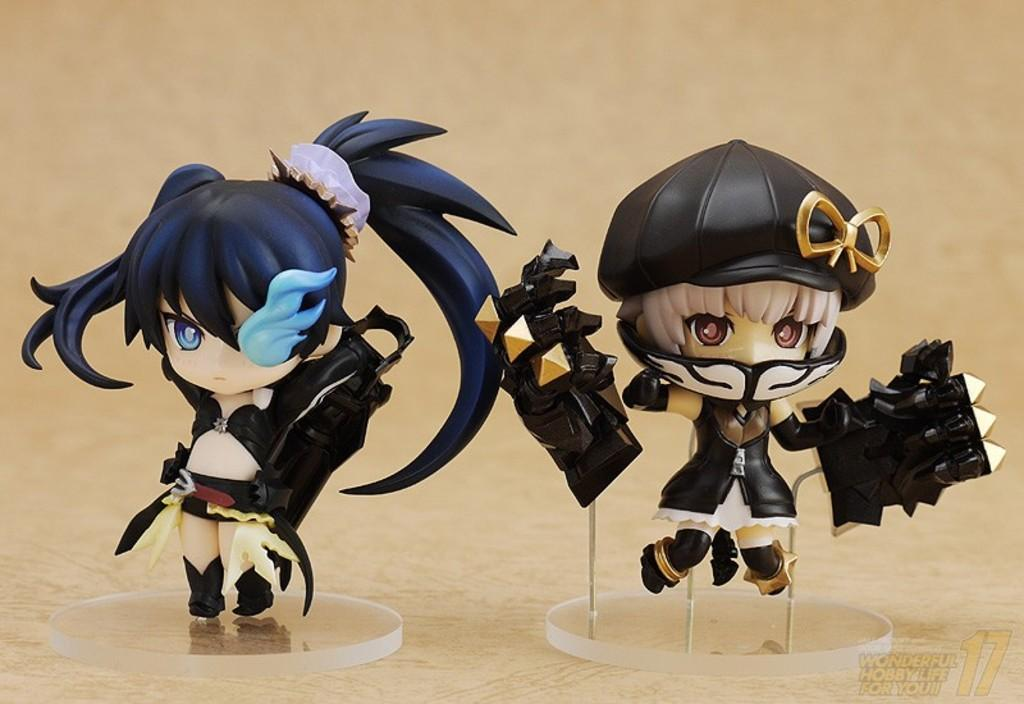What objects can be seen on the wooden surface in the image? There are toys on a wooden surface in the image. Is there any text or logo visible in the image? Yes, there is a watermark at the bottom right side of the image. How would you describe the background of the image? The background of the image is blurry. What time of day is it in the image, and how can you tell? The time of day cannot be determined from the image, as there are no clues or indications of the time. 